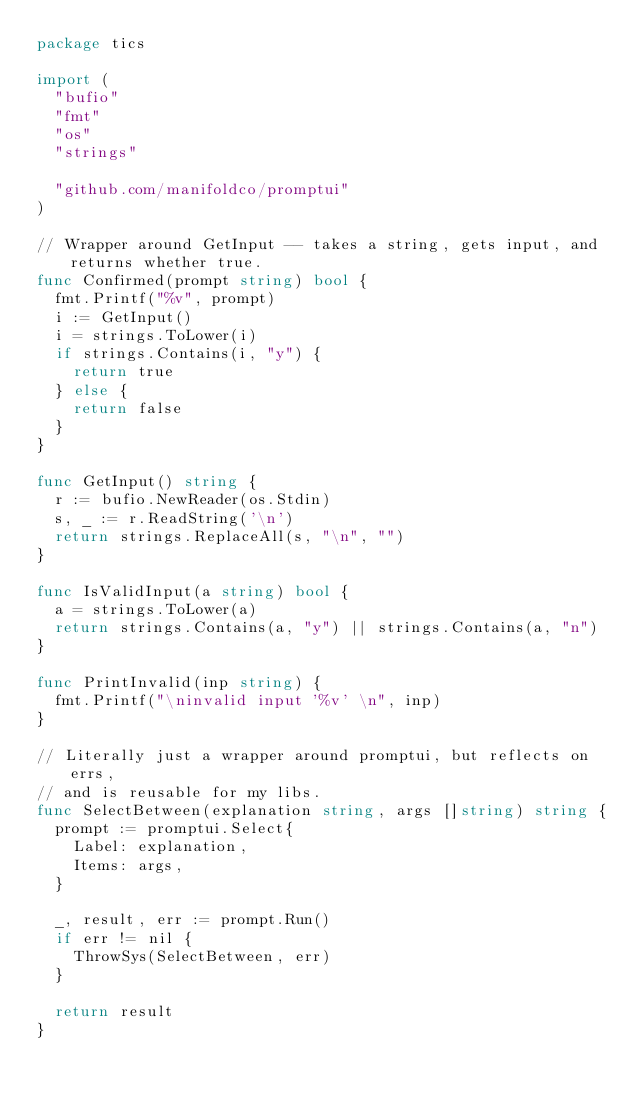<code> <loc_0><loc_0><loc_500><loc_500><_Go_>package tics

import (
	"bufio"
	"fmt"
	"os"
	"strings"

	"github.com/manifoldco/promptui"
)

// Wrapper around GetInput -- takes a string, gets input, and returns whether true.
func Confirmed(prompt string) bool {
	fmt.Printf("%v", prompt)
	i := GetInput()
	i = strings.ToLower(i)
	if strings.Contains(i, "y") {
		return true
	} else {
		return false
	}
}

func GetInput() string {
	r := bufio.NewReader(os.Stdin)
	s, _ := r.ReadString('\n')
	return strings.ReplaceAll(s, "\n", "")
}

func IsValidInput(a string) bool {
	a = strings.ToLower(a)
	return strings.Contains(a, "y") || strings.Contains(a, "n")
}

func PrintInvalid(inp string) {
	fmt.Printf("\ninvalid input '%v' \n", inp)
}

// Literally just a wrapper around promptui, but reflects on errs,
// and is reusable for my libs.
func SelectBetween(explanation string, args []string) string {
	prompt := promptui.Select{
		Label: explanation,
		Items: args,
	}

	_, result, err := prompt.Run()
	if err != nil {
		ThrowSys(SelectBetween, err)
	}

	return result
}
</code> 